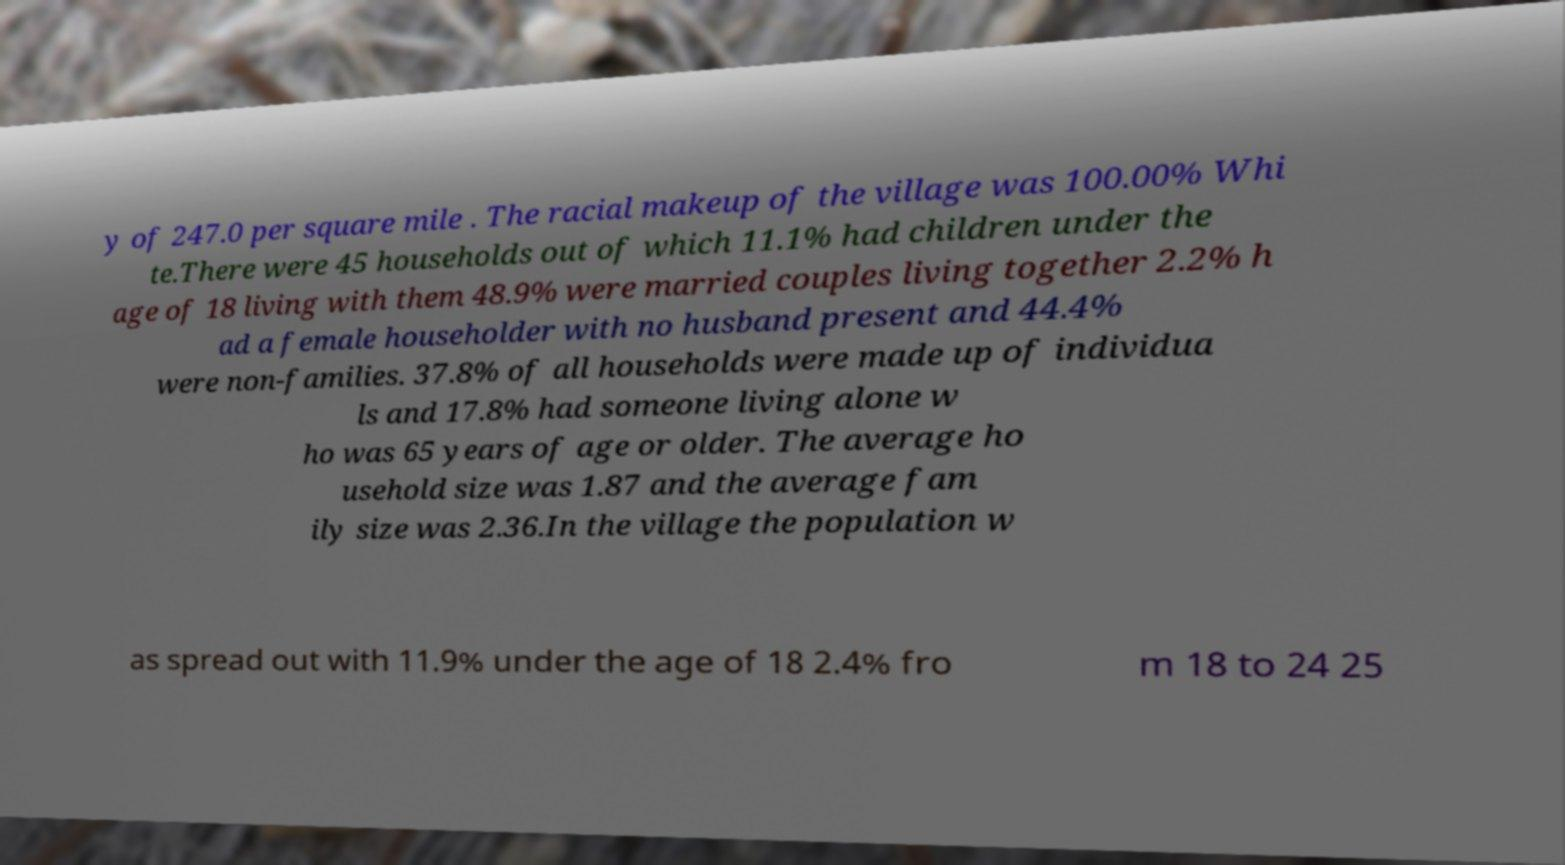Could you assist in decoding the text presented in this image and type it out clearly? y of 247.0 per square mile . The racial makeup of the village was 100.00% Whi te.There were 45 households out of which 11.1% had children under the age of 18 living with them 48.9% were married couples living together 2.2% h ad a female householder with no husband present and 44.4% were non-families. 37.8% of all households were made up of individua ls and 17.8% had someone living alone w ho was 65 years of age or older. The average ho usehold size was 1.87 and the average fam ily size was 2.36.In the village the population w as spread out with 11.9% under the age of 18 2.4% fro m 18 to 24 25 